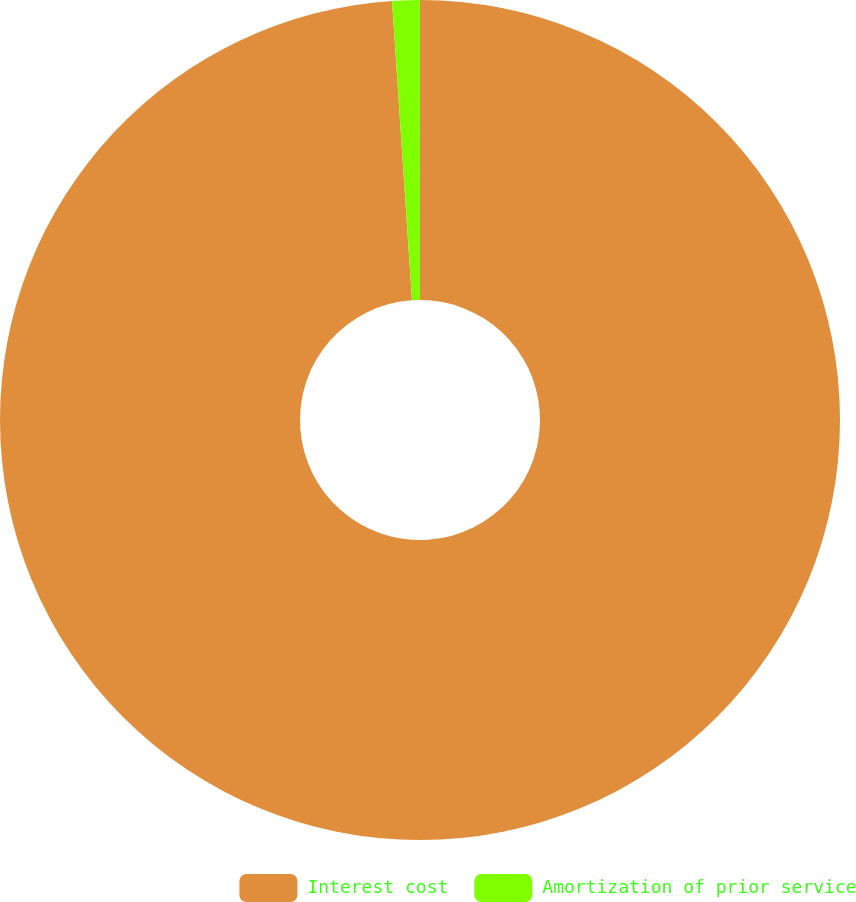Convert chart. <chart><loc_0><loc_0><loc_500><loc_500><pie_chart><fcel>Interest cost<fcel>Amortization of prior service<nl><fcel>98.94%<fcel>1.06%<nl></chart> 